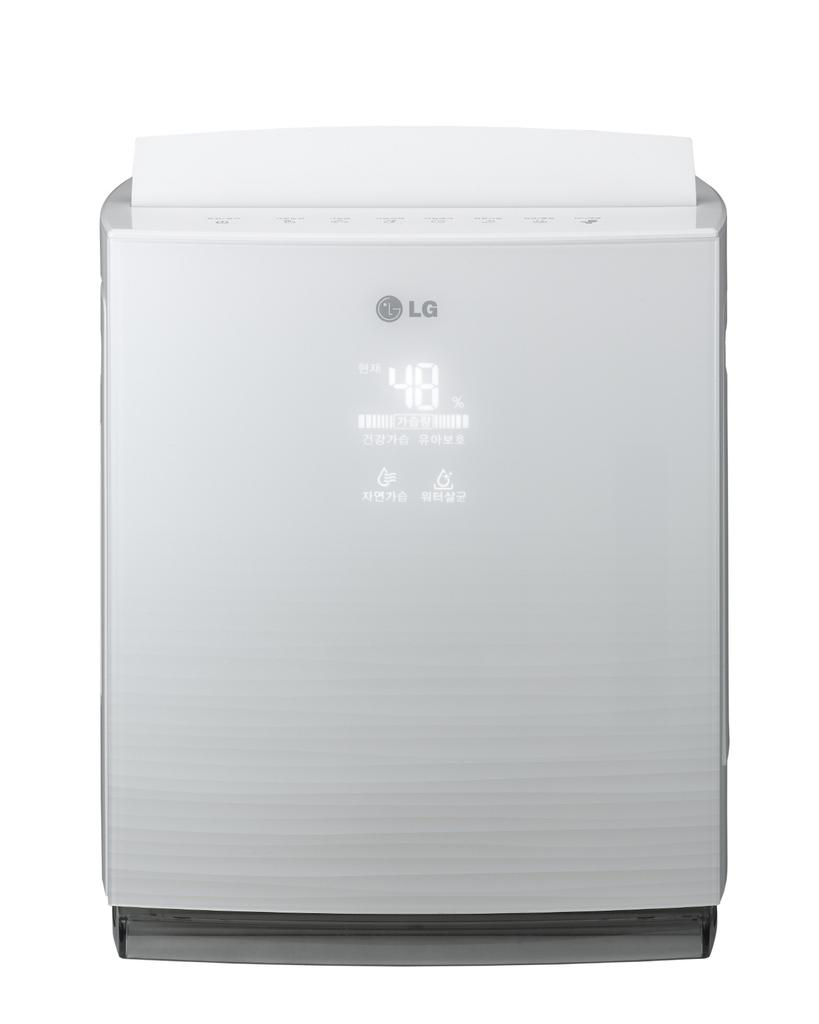<image>
Render a clear and concise summary of the photo. The featured product was manufactured by LG and is at 48%. 